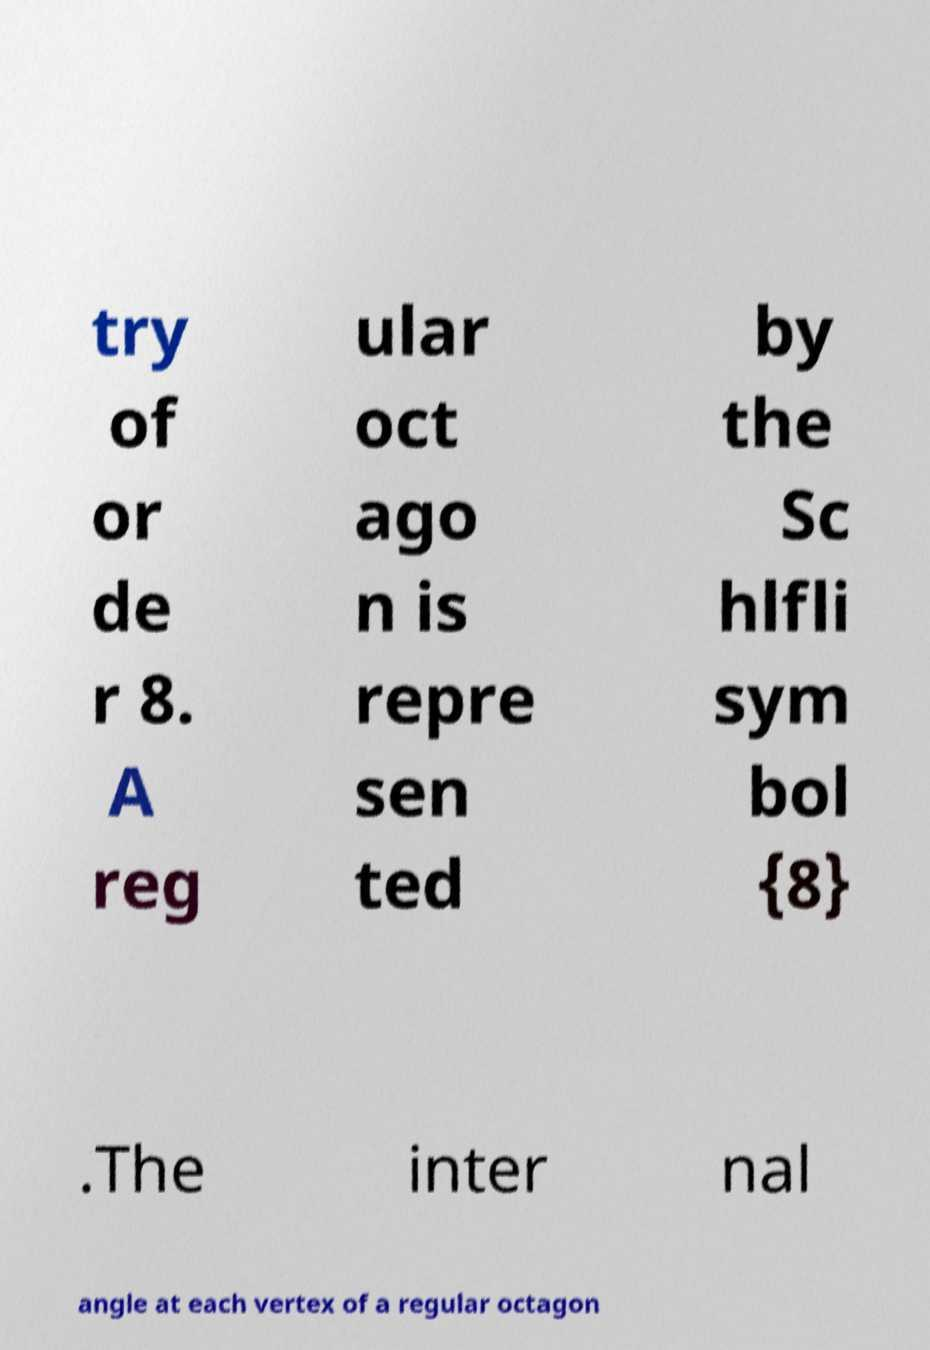I need the written content from this picture converted into text. Can you do that? try of or de r 8. A reg ular oct ago n is repre sen ted by the Sc hlfli sym bol {8} .The inter nal angle at each vertex of a regular octagon 